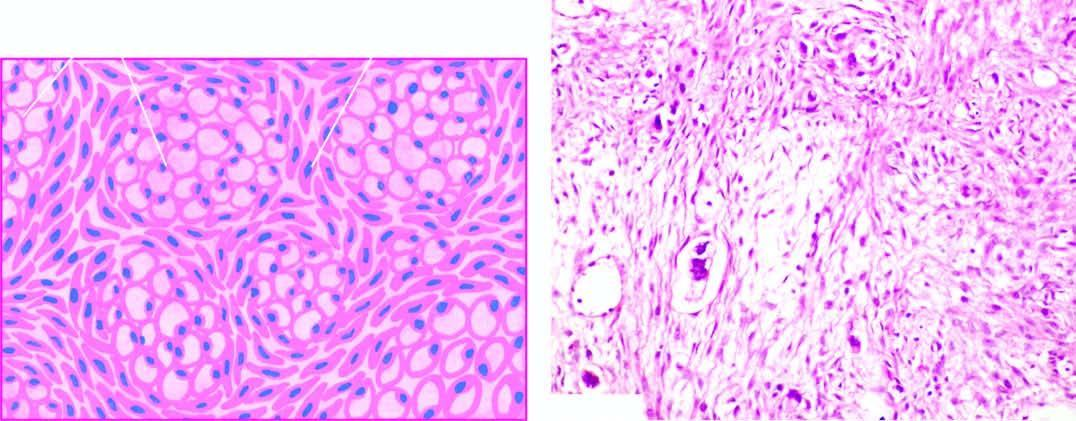what include mucin-filled signet-ring cells and richly cellular proliferation of the ovarian stroma?
Answer the question using a single word or phrase. Histologic features 